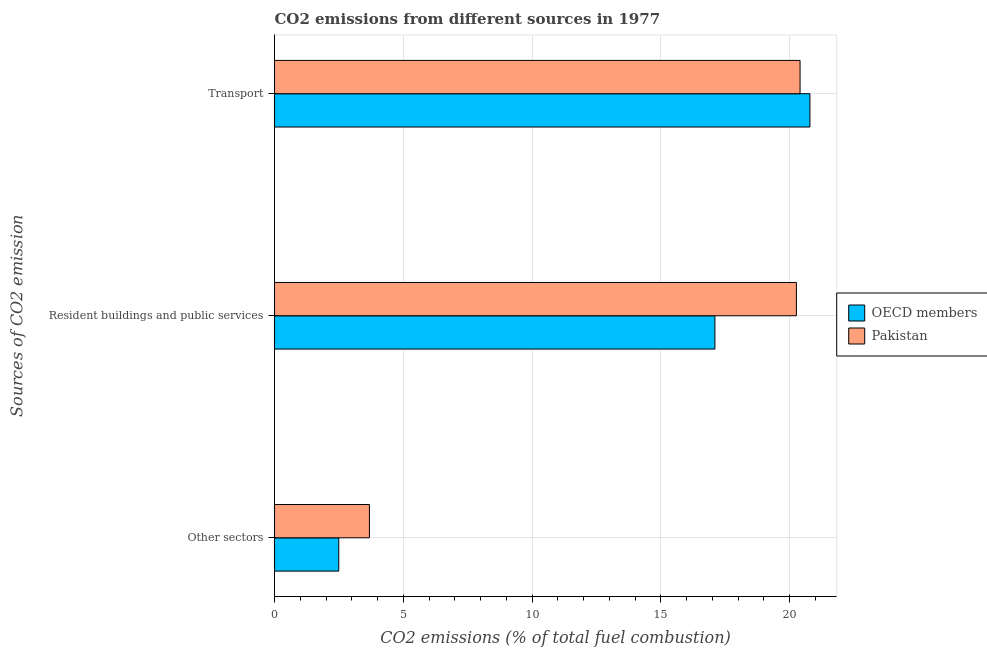Are the number of bars per tick equal to the number of legend labels?
Your response must be concise. Yes. Are the number of bars on each tick of the Y-axis equal?
Provide a short and direct response. Yes. What is the label of the 2nd group of bars from the top?
Offer a very short reply. Resident buildings and public services. What is the percentage of co2 emissions from resident buildings and public services in Pakistan?
Make the answer very short. 20.26. Across all countries, what is the maximum percentage of co2 emissions from transport?
Your answer should be compact. 20.79. Across all countries, what is the minimum percentage of co2 emissions from other sectors?
Provide a succinct answer. 2.49. In which country was the percentage of co2 emissions from other sectors maximum?
Offer a terse response. Pakistan. In which country was the percentage of co2 emissions from transport minimum?
Give a very brief answer. Pakistan. What is the total percentage of co2 emissions from other sectors in the graph?
Make the answer very short. 6.18. What is the difference between the percentage of co2 emissions from resident buildings and public services in OECD members and that in Pakistan?
Your answer should be compact. -3.16. What is the difference between the percentage of co2 emissions from other sectors in Pakistan and the percentage of co2 emissions from transport in OECD members?
Make the answer very short. -17.1. What is the average percentage of co2 emissions from transport per country?
Provide a succinct answer. 20.6. What is the difference between the percentage of co2 emissions from other sectors and percentage of co2 emissions from transport in Pakistan?
Make the answer very short. -16.72. In how many countries, is the percentage of co2 emissions from resident buildings and public services greater than 20 %?
Make the answer very short. 1. What is the ratio of the percentage of co2 emissions from resident buildings and public services in Pakistan to that in OECD members?
Offer a very short reply. 1.19. Is the percentage of co2 emissions from resident buildings and public services in Pakistan less than that in OECD members?
Your answer should be compact. No. What is the difference between the highest and the second highest percentage of co2 emissions from resident buildings and public services?
Your response must be concise. 3.16. What is the difference between the highest and the lowest percentage of co2 emissions from transport?
Your response must be concise. 0.38. In how many countries, is the percentage of co2 emissions from transport greater than the average percentage of co2 emissions from transport taken over all countries?
Your response must be concise. 1. What does the 2nd bar from the bottom in Resident buildings and public services represents?
Your answer should be very brief. Pakistan. Is it the case that in every country, the sum of the percentage of co2 emissions from other sectors and percentage of co2 emissions from resident buildings and public services is greater than the percentage of co2 emissions from transport?
Offer a terse response. No. How many bars are there?
Your answer should be compact. 6. Are all the bars in the graph horizontal?
Your answer should be compact. Yes. What is the difference between two consecutive major ticks on the X-axis?
Your response must be concise. 5. Are the values on the major ticks of X-axis written in scientific E-notation?
Make the answer very short. No. Does the graph contain grids?
Ensure brevity in your answer.  Yes. What is the title of the graph?
Offer a terse response. CO2 emissions from different sources in 1977. Does "Middle income" appear as one of the legend labels in the graph?
Your response must be concise. No. What is the label or title of the X-axis?
Ensure brevity in your answer.  CO2 emissions (% of total fuel combustion). What is the label or title of the Y-axis?
Your answer should be very brief. Sources of CO2 emission. What is the CO2 emissions (% of total fuel combustion) of OECD members in Other sectors?
Keep it short and to the point. 2.49. What is the CO2 emissions (% of total fuel combustion) in Pakistan in Other sectors?
Give a very brief answer. 3.68. What is the CO2 emissions (% of total fuel combustion) of OECD members in Resident buildings and public services?
Make the answer very short. 17.1. What is the CO2 emissions (% of total fuel combustion) in Pakistan in Resident buildings and public services?
Make the answer very short. 20.26. What is the CO2 emissions (% of total fuel combustion) in OECD members in Transport?
Keep it short and to the point. 20.79. What is the CO2 emissions (% of total fuel combustion) of Pakistan in Transport?
Ensure brevity in your answer.  20.41. Across all Sources of CO2 emission, what is the maximum CO2 emissions (% of total fuel combustion) in OECD members?
Provide a short and direct response. 20.79. Across all Sources of CO2 emission, what is the maximum CO2 emissions (% of total fuel combustion) in Pakistan?
Your answer should be compact. 20.41. Across all Sources of CO2 emission, what is the minimum CO2 emissions (% of total fuel combustion) in OECD members?
Make the answer very short. 2.49. Across all Sources of CO2 emission, what is the minimum CO2 emissions (% of total fuel combustion) of Pakistan?
Offer a terse response. 3.68. What is the total CO2 emissions (% of total fuel combustion) in OECD members in the graph?
Your answer should be compact. 40.38. What is the total CO2 emissions (% of total fuel combustion) of Pakistan in the graph?
Make the answer very short. 44.36. What is the difference between the CO2 emissions (% of total fuel combustion) of OECD members in Other sectors and that in Resident buildings and public services?
Your response must be concise. -14.61. What is the difference between the CO2 emissions (% of total fuel combustion) of Pakistan in Other sectors and that in Resident buildings and public services?
Offer a very short reply. -16.58. What is the difference between the CO2 emissions (% of total fuel combustion) of OECD members in Other sectors and that in Transport?
Provide a short and direct response. -18.3. What is the difference between the CO2 emissions (% of total fuel combustion) in Pakistan in Other sectors and that in Transport?
Ensure brevity in your answer.  -16.72. What is the difference between the CO2 emissions (% of total fuel combustion) in OECD members in Resident buildings and public services and that in Transport?
Your answer should be compact. -3.69. What is the difference between the CO2 emissions (% of total fuel combustion) of Pakistan in Resident buildings and public services and that in Transport?
Offer a terse response. -0.14. What is the difference between the CO2 emissions (% of total fuel combustion) of OECD members in Other sectors and the CO2 emissions (% of total fuel combustion) of Pakistan in Resident buildings and public services?
Keep it short and to the point. -17.77. What is the difference between the CO2 emissions (% of total fuel combustion) in OECD members in Other sectors and the CO2 emissions (% of total fuel combustion) in Pakistan in Transport?
Your answer should be compact. -17.91. What is the difference between the CO2 emissions (% of total fuel combustion) of OECD members in Resident buildings and public services and the CO2 emissions (% of total fuel combustion) of Pakistan in Transport?
Your response must be concise. -3.31. What is the average CO2 emissions (% of total fuel combustion) in OECD members per Sources of CO2 emission?
Offer a terse response. 13.46. What is the average CO2 emissions (% of total fuel combustion) in Pakistan per Sources of CO2 emission?
Your answer should be very brief. 14.79. What is the difference between the CO2 emissions (% of total fuel combustion) of OECD members and CO2 emissions (% of total fuel combustion) of Pakistan in Other sectors?
Your response must be concise. -1.19. What is the difference between the CO2 emissions (% of total fuel combustion) of OECD members and CO2 emissions (% of total fuel combustion) of Pakistan in Resident buildings and public services?
Your answer should be compact. -3.16. What is the difference between the CO2 emissions (% of total fuel combustion) in OECD members and CO2 emissions (% of total fuel combustion) in Pakistan in Transport?
Give a very brief answer. 0.38. What is the ratio of the CO2 emissions (% of total fuel combustion) in OECD members in Other sectors to that in Resident buildings and public services?
Ensure brevity in your answer.  0.15. What is the ratio of the CO2 emissions (% of total fuel combustion) of Pakistan in Other sectors to that in Resident buildings and public services?
Your answer should be very brief. 0.18. What is the ratio of the CO2 emissions (% of total fuel combustion) of OECD members in Other sectors to that in Transport?
Keep it short and to the point. 0.12. What is the ratio of the CO2 emissions (% of total fuel combustion) in Pakistan in Other sectors to that in Transport?
Keep it short and to the point. 0.18. What is the ratio of the CO2 emissions (% of total fuel combustion) of OECD members in Resident buildings and public services to that in Transport?
Offer a terse response. 0.82. What is the ratio of the CO2 emissions (% of total fuel combustion) of Pakistan in Resident buildings and public services to that in Transport?
Provide a short and direct response. 0.99. What is the difference between the highest and the second highest CO2 emissions (% of total fuel combustion) of OECD members?
Give a very brief answer. 3.69. What is the difference between the highest and the second highest CO2 emissions (% of total fuel combustion) of Pakistan?
Offer a terse response. 0.14. What is the difference between the highest and the lowest CO2 emissions (% of total fuel combustion) in OECD members?
Your answer should be very brief. 18.3. What is the difference between the highest and the lowest CO2 emissions (% of total fuel combustion) of Pakistan?
Your answer should be very brief. 16.72. 